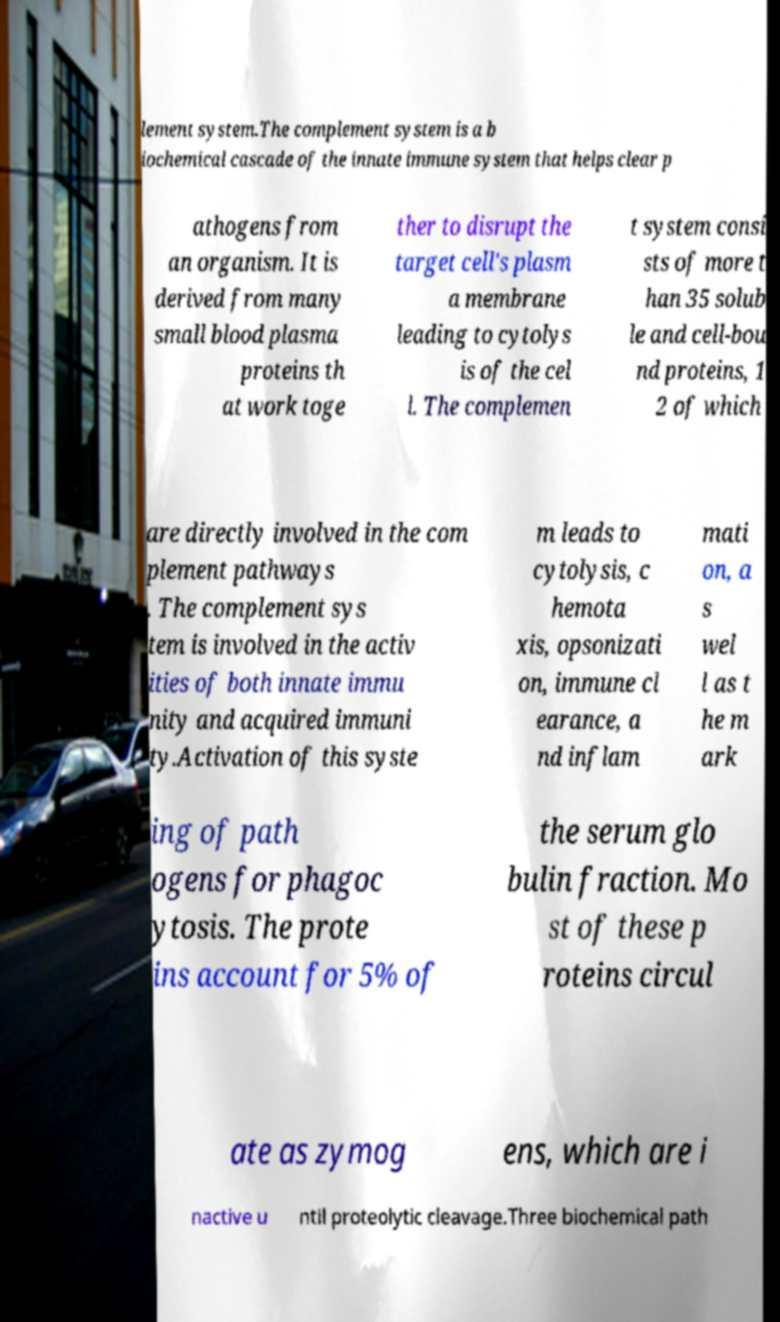Could you assist in decoding the text presented in this image and type it out clearly? lement system.The complement system is a b iochemical cascade of the innate immune system that helps clear p athogens from an organism. It is derived from many small blood plasma proteins th at work toge ther to disrupt the target cell's plasm a membrane leading to cytolys is of the cel l. The complemen t system consi sts of more t han 35 solub le and cell-bou nd proteins, 1 2 of which are directly involved in the com plement pathways . The complement sys tem is involved in the activ ities of both innate immu nity and acquired immuni ty.Activation of this syste m leads to cytolysis, c hemota xis, opsonizati on, immune cl earance, a nd inflam mati on, a s wel l as t he m ark ing of path ogens for phagoc ytosis. The prote ins account for 5% of the serum glo bulin fraction. Mo st of these p roteins circul ate as zymog ens, which are i nactive u ntil proteolytic cleavage.Three biochemical path 